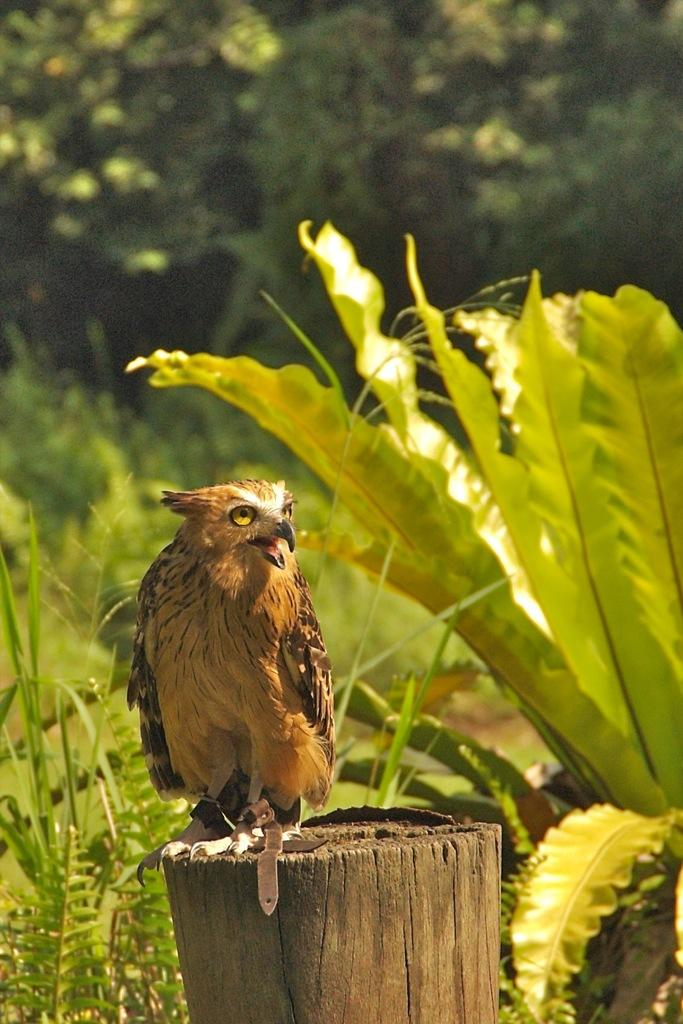What type of animal is in the image? There is a bird in the image. Where is the bird located? The bird is on a wooden trunk. What can be seen in the background of the image? There are plants and trees in the background of the image. What type of pail is being used by the bird in the image? There is no pail present in the image; the bird is on a wooden trunk. How does the bird's death contribute to the scene in the image? There is no indication of the bird's death in the image, as the bird is perched on a wooden trunk. 